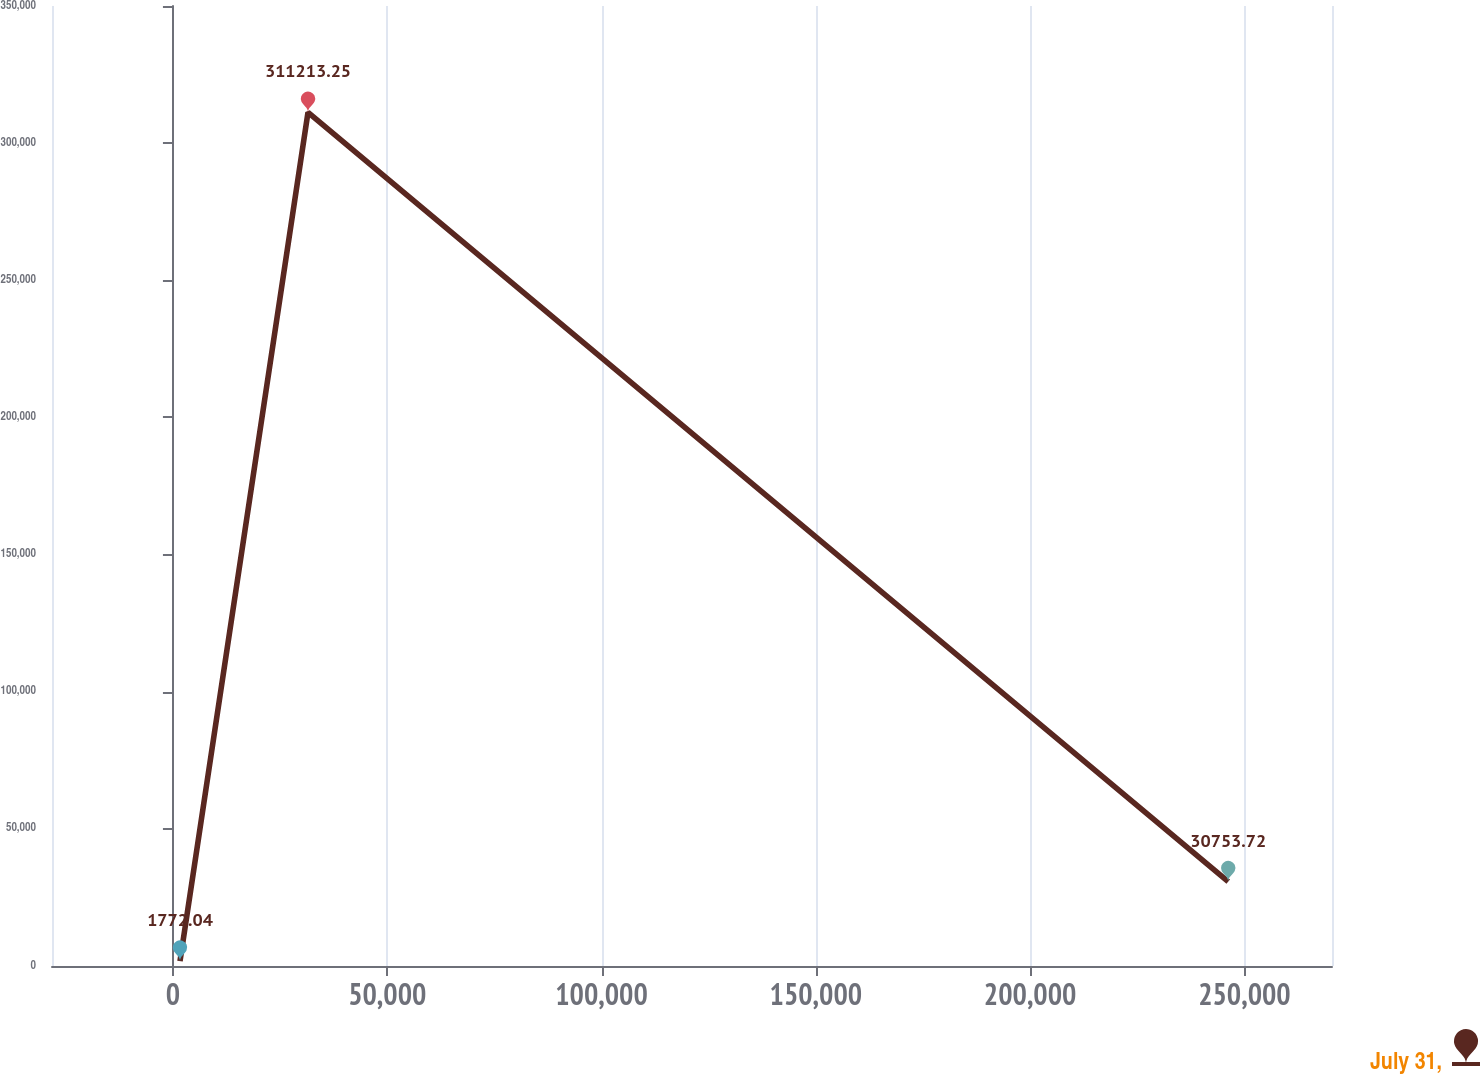Convert chart. <chart><loc_0><loc_0><loc_500><loc_500><line_chart><ecel><fcel>July 31,<nl><fcel>1647.28<fcel>1772.04<nl><fcel>31512.5<fcel>311213<nl><fcel>246222<fcel>30753.7<nl><fcel>300300<fcel>282232<nl></chart> 